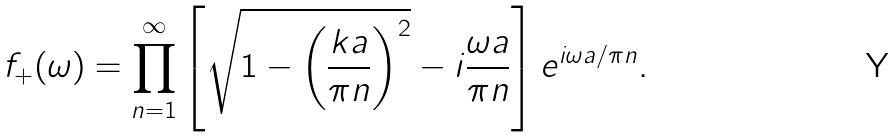<formula> <loc_0><loc_0><loc_500><loc_500>f _ { + } ( \omega ) = \prod _ { n = 1 } ^ { \infty } \left [ \sqrt { 1 - \left ( \frac { k a } { \pi n } \right ) ^ { 2 } } - i \frac { \omega a } { \pi n } \right ] e ^ { i \omega a / \pi n } .</formula> 